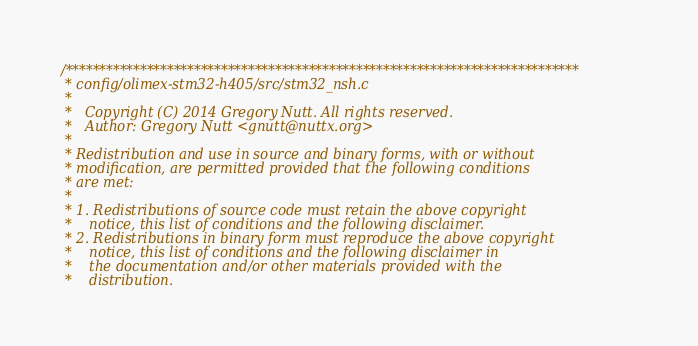<code> <loc_0><loc_0><loc_500><loc_500><_C_>/****************************************************************************
 * config/olimex-stm32-h405/src/stm32_nsh.c
 *
 *   Copyright (C) 2014 Gregory Nutt. All rights reserved.
 *   Author: Gregory Nutt <gnutt@nuttx.org>
 *
 * Redistribution and use in source and binary forms, with or without
 * modification, are permitted provided that the following conditions
 * are met:
 *
 * 1. Redistributions of source code must retain the above copyright
 *    notice, this list of conditions and the following disclaimer.
 * 2. Redistributions in binary form must reproduce the above copyright
 *    notice, this list of conditions and the following disclaimer in
 *    the documentation and/or other materials provided with the
 *    distribution.</code> 